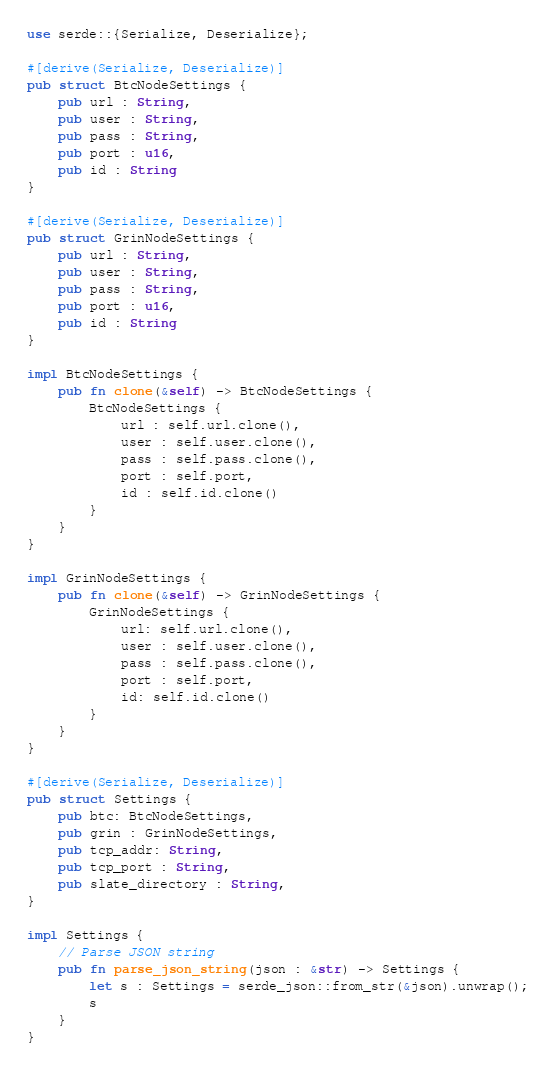<code> <loc_0><loc_0><loc_500><loc_500><_Rust_>use serde::{Serialize, Deserialize};

#[derive(Serialize, Deserialize)]
pub struct BtcNodeSettings {
    pub url : String,
    pub user : String,
    pub pass : String,
    pub port : u16,
    pub id : String
}

#[derive(Serialize, Deserialize)]
pub struct GrinNodeSettings {
    pub url : String,
    pub user : String,
    pub pass : String,
    pub port : u16,
    pub id : String
}

impl BtcNodeSettings {
    pub fn clone(&self) -> BtcNodeSettings {
        BtcNodeSettings {
            url : self.url.clone(),
            user : self.user.clone(),
            pass : self.pass.clone(),
            port : self.port,
            id : self.id.clone()
        }
    }
}

impl GrinNodeSettings {
    pub fn clone(&self) -> GrinNodeSettings {
        GrinNodeSettings {
            url: self.url.clone(),
            user : self.user.clone(),
            pass : self.pass.clone(),
            port : self.port,
            id: self.id.clone()
        }
    }
}

#[derive(Serialize, Deserialize)]
pub struct Settings {
    pub btc: BtcNodeSettings,
    pub grin : GrinNodeSettings,
    pub tcp_addr: String,
    pub tcp_port : String,
    pub slate_directory : String,
}

impl Settings {
    // Parse JSON string
    pub fn parse_json_string(json : &str) -> Settings {
        let s : Settings = serde_json::from_str(&json).unwrap();
        s
    }
}</code> 